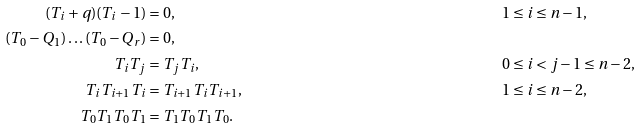<formula> <loc_0><loc_0><loc_500><loc_500>( T _ { i } + q ) ( T _ { i } - 1 ) & = 0 , & 1 & \leq i \leq n - 1 , \\ ( T _ { 0 } - Q _ { 1 } ) \dots ( T _ { 0 } - Q _ { r } ) & = 0 , & & \\ T _ { i } T _ { j } & = T _ { j } T _ { i } , & 0 & \leq i < j - 1 \leq n - 2 , \\ T _ { i } T _ { i + 1 } T _ { i } & = T _ { i + 1 } T _ { i } T _ { i + 1 } , & 1 & \leq i \leq n - 2 , \\ T _ { 0 } T _ { 1 } T _ { 0 } T _ { 1 } & = T _ { 1 } T _ { 0 } T _ { 1 } T _ { 0 } . & &</formula> 